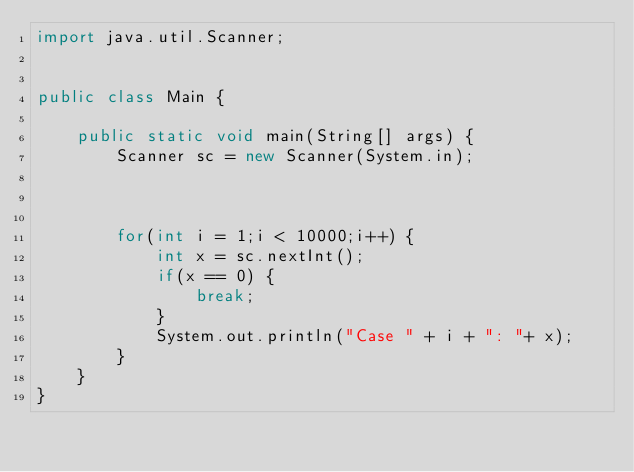Convert code to text. <code><loc_0><loc_0><loc_500><loc_500><_Java_>import java.util.Scanner;


public class Main {

	public static void main(String[] args) {
		Scanner sc = new Scanner(System.in);



		for(int i = 1;i < 10000;i++) {
			int x = sc.nextInt();
			if(x == 0) {
				break;
			}
			System.out.println("Case " + i + ": "+ x);
		}
	}
}

</code> 